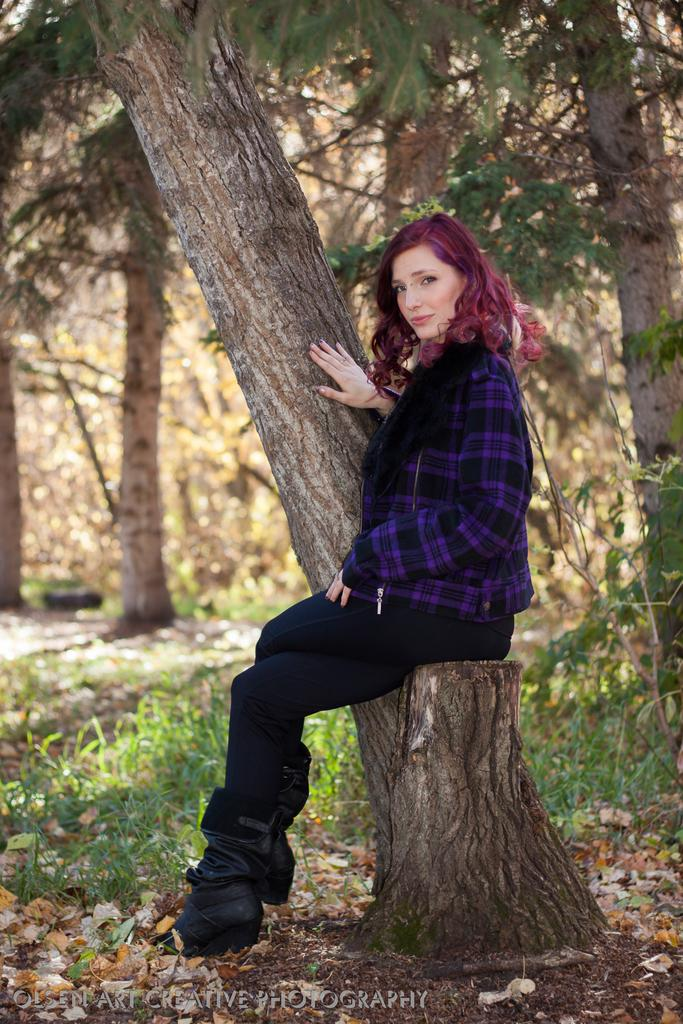What is the lady in the image sitting on? The lady is sitting on a tree trunk in the image. What type of vegetation is visible at the bottom of the image? There is grass at the bottom of the image. What can be seen in the background of the image? There are trees in the background of the image. How many ducks are visible in the image? There are no ducks present in the image. What type of rail is supporting the tree trunk in the image? There is no rail visible in the image; the lady is sitting directly on the tree trunk. 